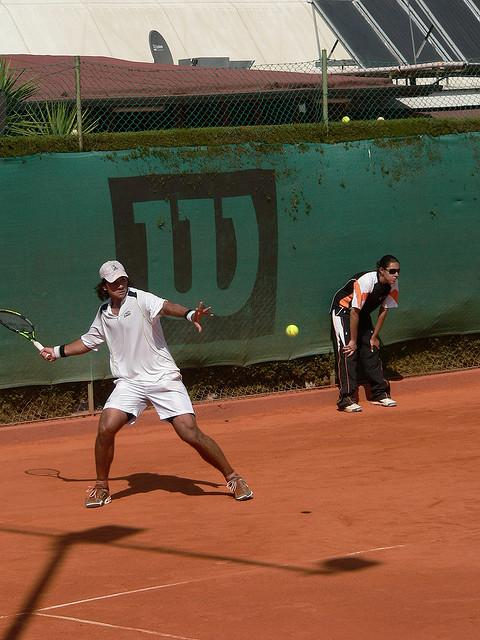What powers the facilities in this area? Please explain your reasoning. solar. There are panels up above that catch the rays 